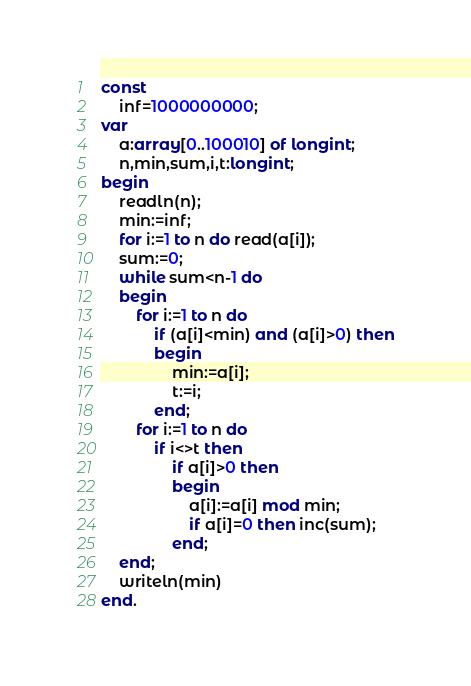Convert code to text. <code><loc_0><loc_0><loc_500><loc_500><_Pascal_>const
	inf=1000000000;
var
	a:array[0..100010] of longint;
	n,min,sum,i,t:longint;
begin
	readln(n);
	min:=inf;
	for i:=1 to n do read(a[i]);
	sum:=0;
	while sum<n-1 do
	begin
		for i:=1 to n do
			if (a[i]<min) and (a[i]>0) then
			begin 
				min:=a[i];
				t:=i;
			end;
		for i:=1 to n do
			if i<>t then 
				if a[i]>0 then 
				begin
					a[i]:=a[i] mod min;
					if a[i]=0 then inc(sum);
				end;
	end;
	writeln(min)
end.</code> 